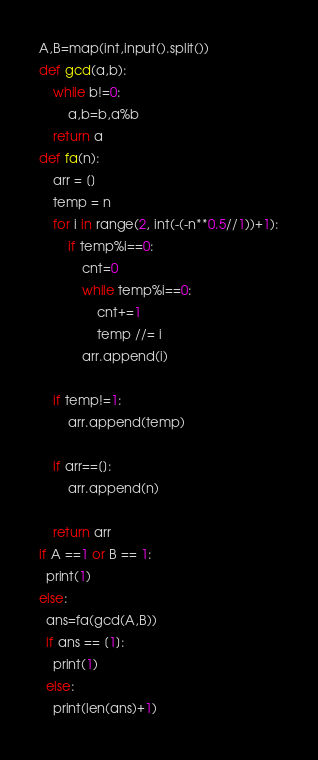Convert code to text. <code><loc_0><loc_0><loc_500><loc_500><_Python_>A,B=map(int,input().split())
def gcd(a,b):
    while b!=0:
        a,b=b,a%b
    return a
def fa(n):
    arr = []
    temp = n
    for i in range(2, int(-(-n**0.5//1))+1):
        if temp%i==0:
            cnt=0
            while temp%i==0:
                cnt+=1
                temp //= i
            arr.append(i)

    if temp!=1:
        arr.append(temp)

    if arr==[]:
        arr.append(n)

    return arr
if A ==1 or B == 1:
  print(1)
else:
  ans=fa(gcd(A,B))
  if ans == [1]:
    print(1)
  else:
    print(len(ans)+1)</code> 